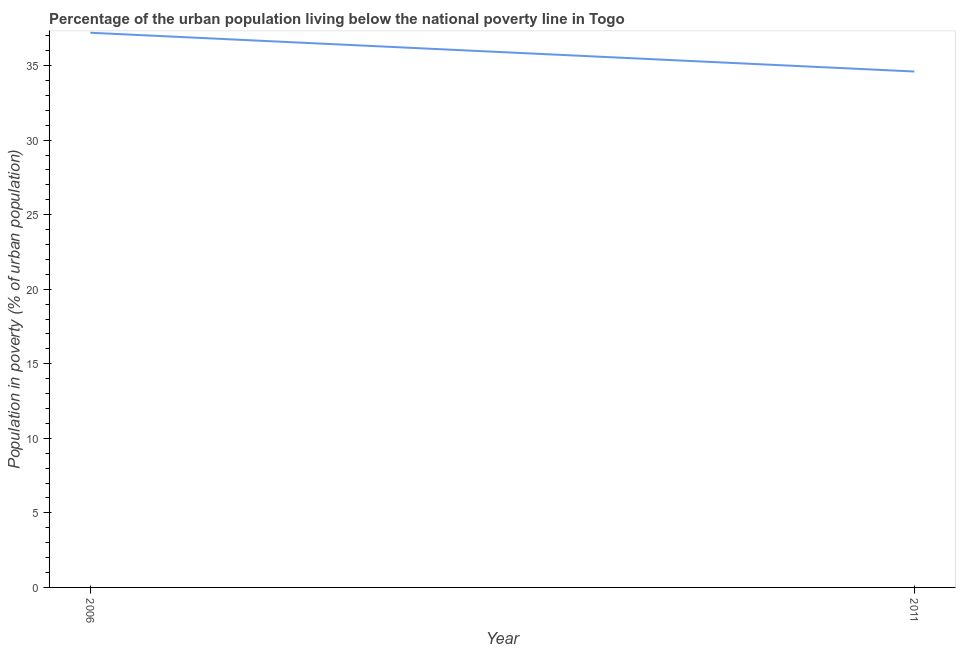What is the percentage of urban population living below poverty line in 2011?
Offer a very short reply. 34.6. Across all years, what is the maximum percentage of urban population living below poverty line?
Ensure brevity in your answer.  37.2. Across all years, what is the minimum percentage of urban population living below poverty line?
Your answer should be compact. 34.6. What is the sum of the percentage of urban population living below poverty line?
Make the answer very short. 71.8. What is the difference between the percentage of urban population living below poverty line in 2006 and 2011?
Offer a very short reply. 2.6. What is the average percentage of urban population living below poverty line per year?
Provide a short and direct response. 35.9. What is the median percentage of urban population living below poverty line?
Your answer should be very brief. 35.9. In how many years, is the percentage of urban population living below poverty line greater than 25 %?
Give a very brief answer. 2. Do a majority of the years between 2006 and 2011 (inclusive) have percentage of urban population living below poverty line greater than 8 %?
Your answer should be very brief. Yes. What is the ratio of the percentage of urban population living below poverty line in 2006 to that in 2011?
Ensure brevity in your answer.  1.08. How many lines are there?
Provide a short and direct response. 1. How many years are there in the graph?
Your answer should be compact. 2. Are the values on the major ticks of Y-axis written in scientific E-notation?
Make the answer very short. No. Does the graph contain any zero values?
Provide a short and direct response. No. What is the title of the graph?
Provide a succinct answer. Percentage of the urban population living below the national poverty line in Togo. What is the label or title of the X-axis?
Keep it short and to the point. Year. What is the label or title of the Y-axis?
Make the answer very short. Population in poverty (% of urban population). What is the Population in poverty (% of urban population) in 2006?
Give a very brief answer. 37.2. What is the Population in poverty (% of urban population) of 2011?
Provide a short and direct response. 34.6. What is the difference between the Population in poverty (% of urban population) in 2006 and 2011?
Offer a very short reply. 2.6. What is the ratio of the Population in poverty (% of urban population) in 2006 to that in 2011?
Keep it short and to the point. 1.07. 